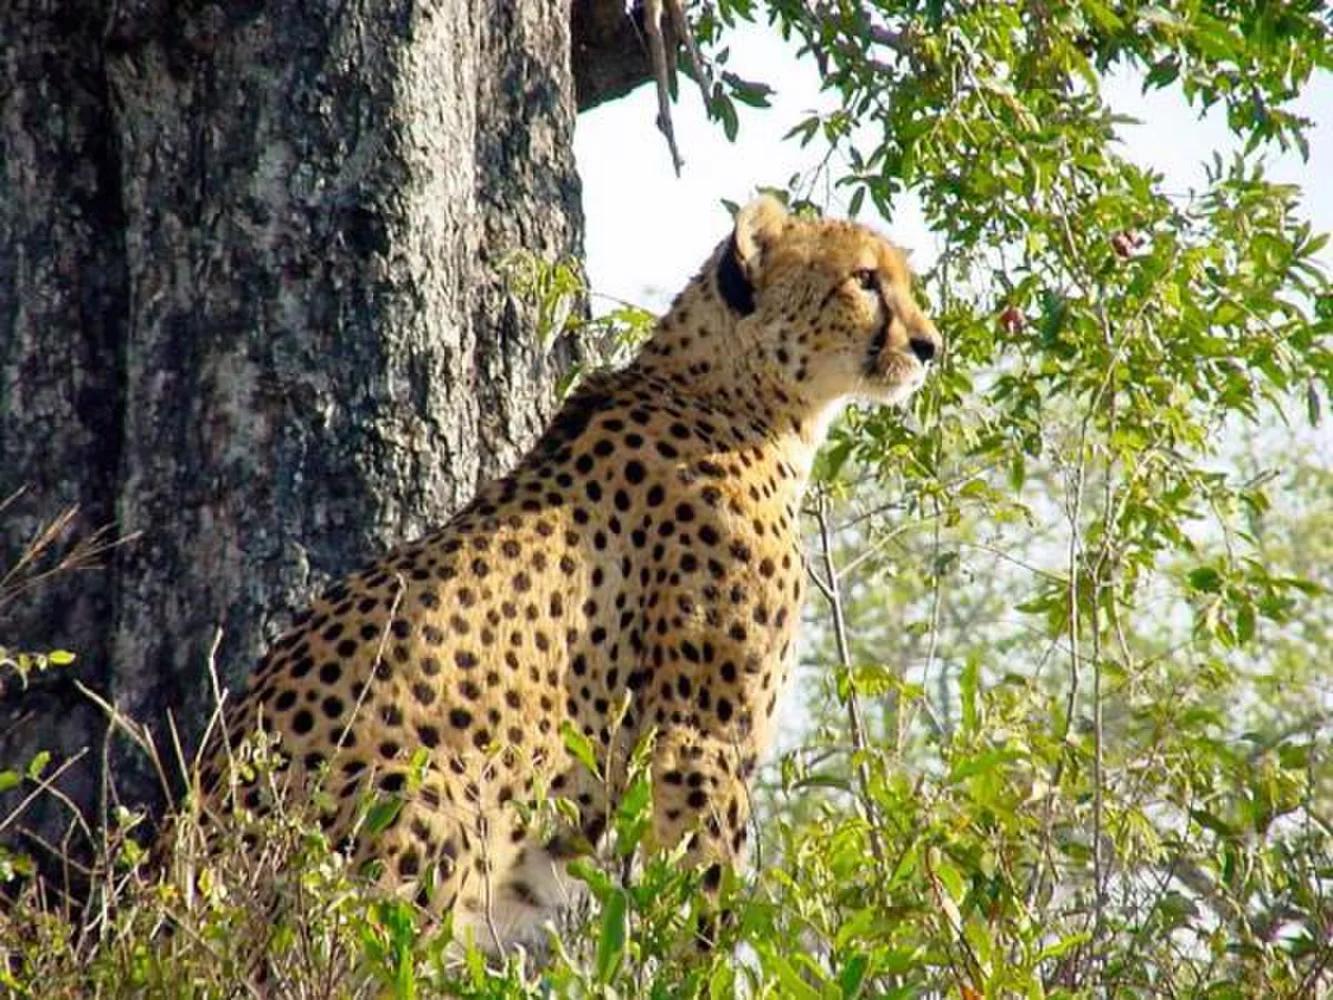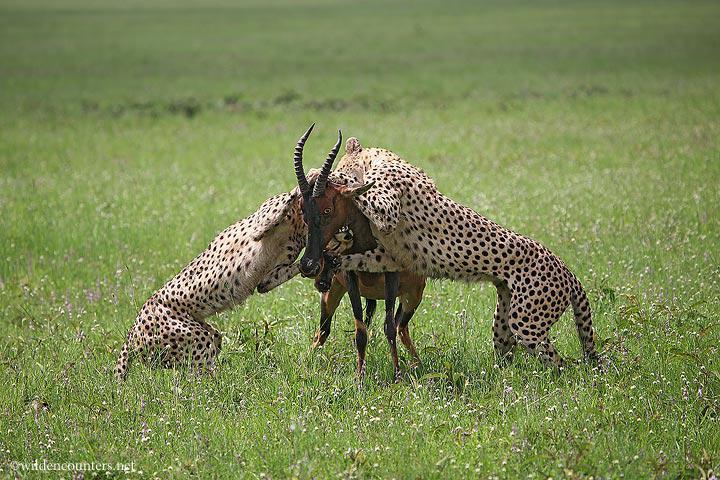The first image is the image on the left, the second image is the image on the right. Evaluate the accuracy of this statement regarding the images: "There are two cheetahs in the image pair". Is it true? Answer yes or no. No. The first image is the image on the left, the second image is the image on the right. Considering the images on both sides, is "There are three cheetahs." valid? Answer yes or no. Yes. 